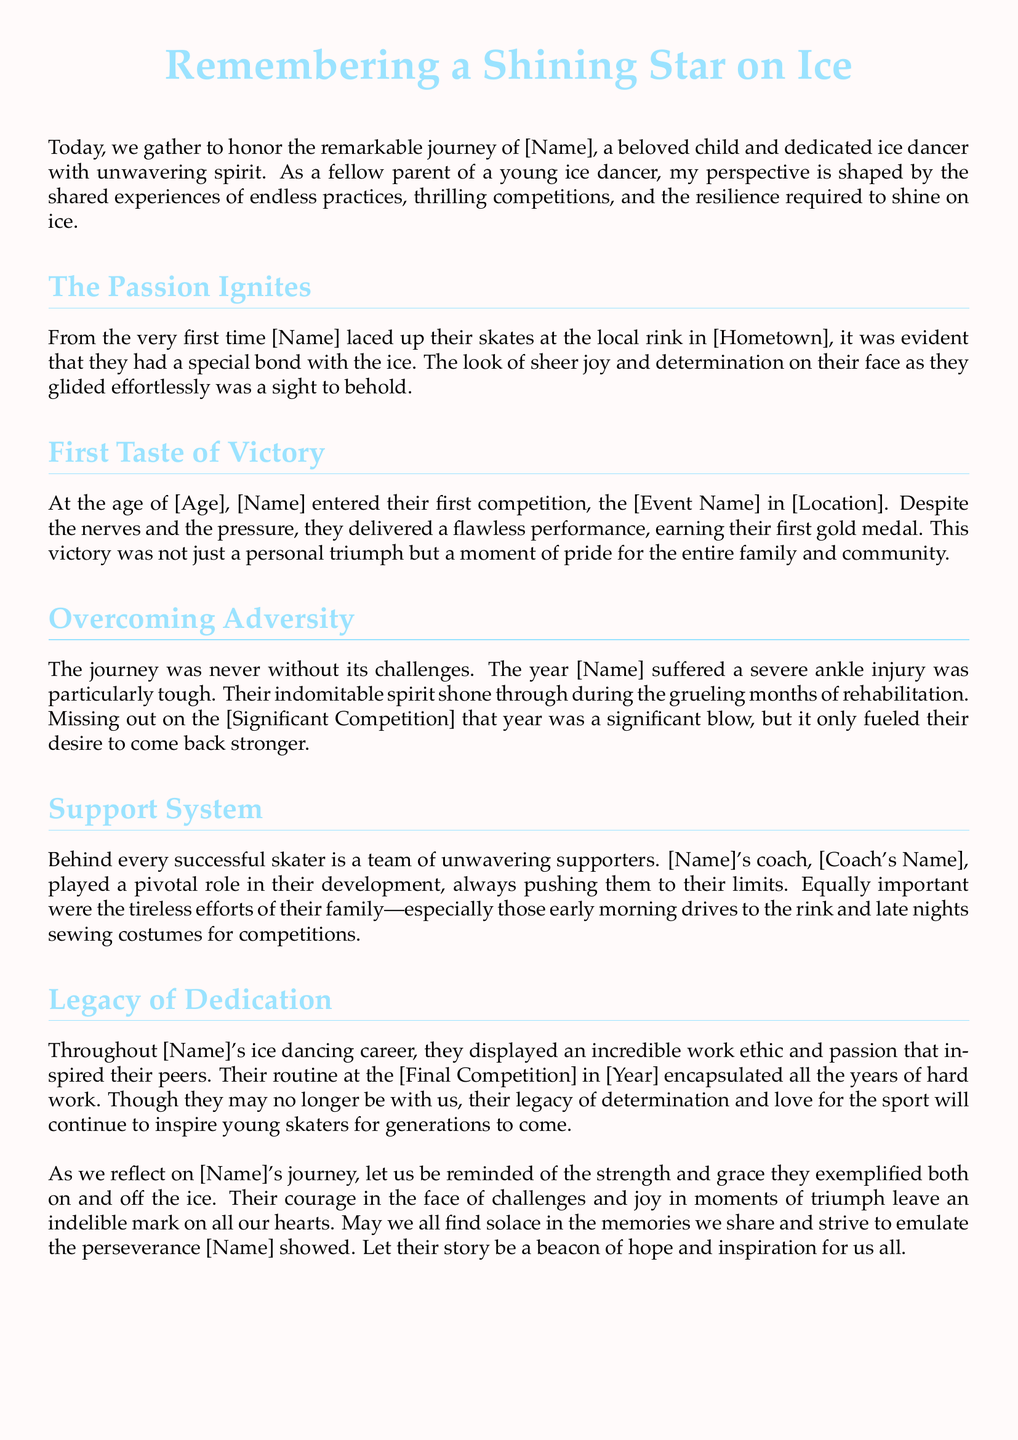What is the main theme of the eulogy? The eulogy focuses on the journey of [Name], highlighting their passion for ice dancing and the challenges they faced.
Answer: Triumphs and Trials on Ice Where did [Name] begin their ice dancing journey? The document mentions the location where [Name] first skated.
Answer: [Hometown] What was [Name]'s first competition? The eulogy identifies the first competitive event [Name] participated in at a young age.
Answer: [Event Name] What medal did [Name] win in their first competition? The document states the outcome of [Name]'s first performance.
Answer: Gold medal What significant injury did [Name] suffer? The eulogy describes a challenging event in [Name]'s career related to health.
Answer: Ankle injury Who played a pivotal role in [Name]'s development? The document points out an important figure in [Name]'s ice dancing journey.
Answer: [Coach's Name] What did [Name]'s routine at the final competition encapsulate? The text summarizes what [Name]'s final performance represented in their career.
Answer: Years of hard work What is a key message from [Name]'s story? The eulogy conveys a message about resilience and inspiration.
Answer: Hope and inspiration 